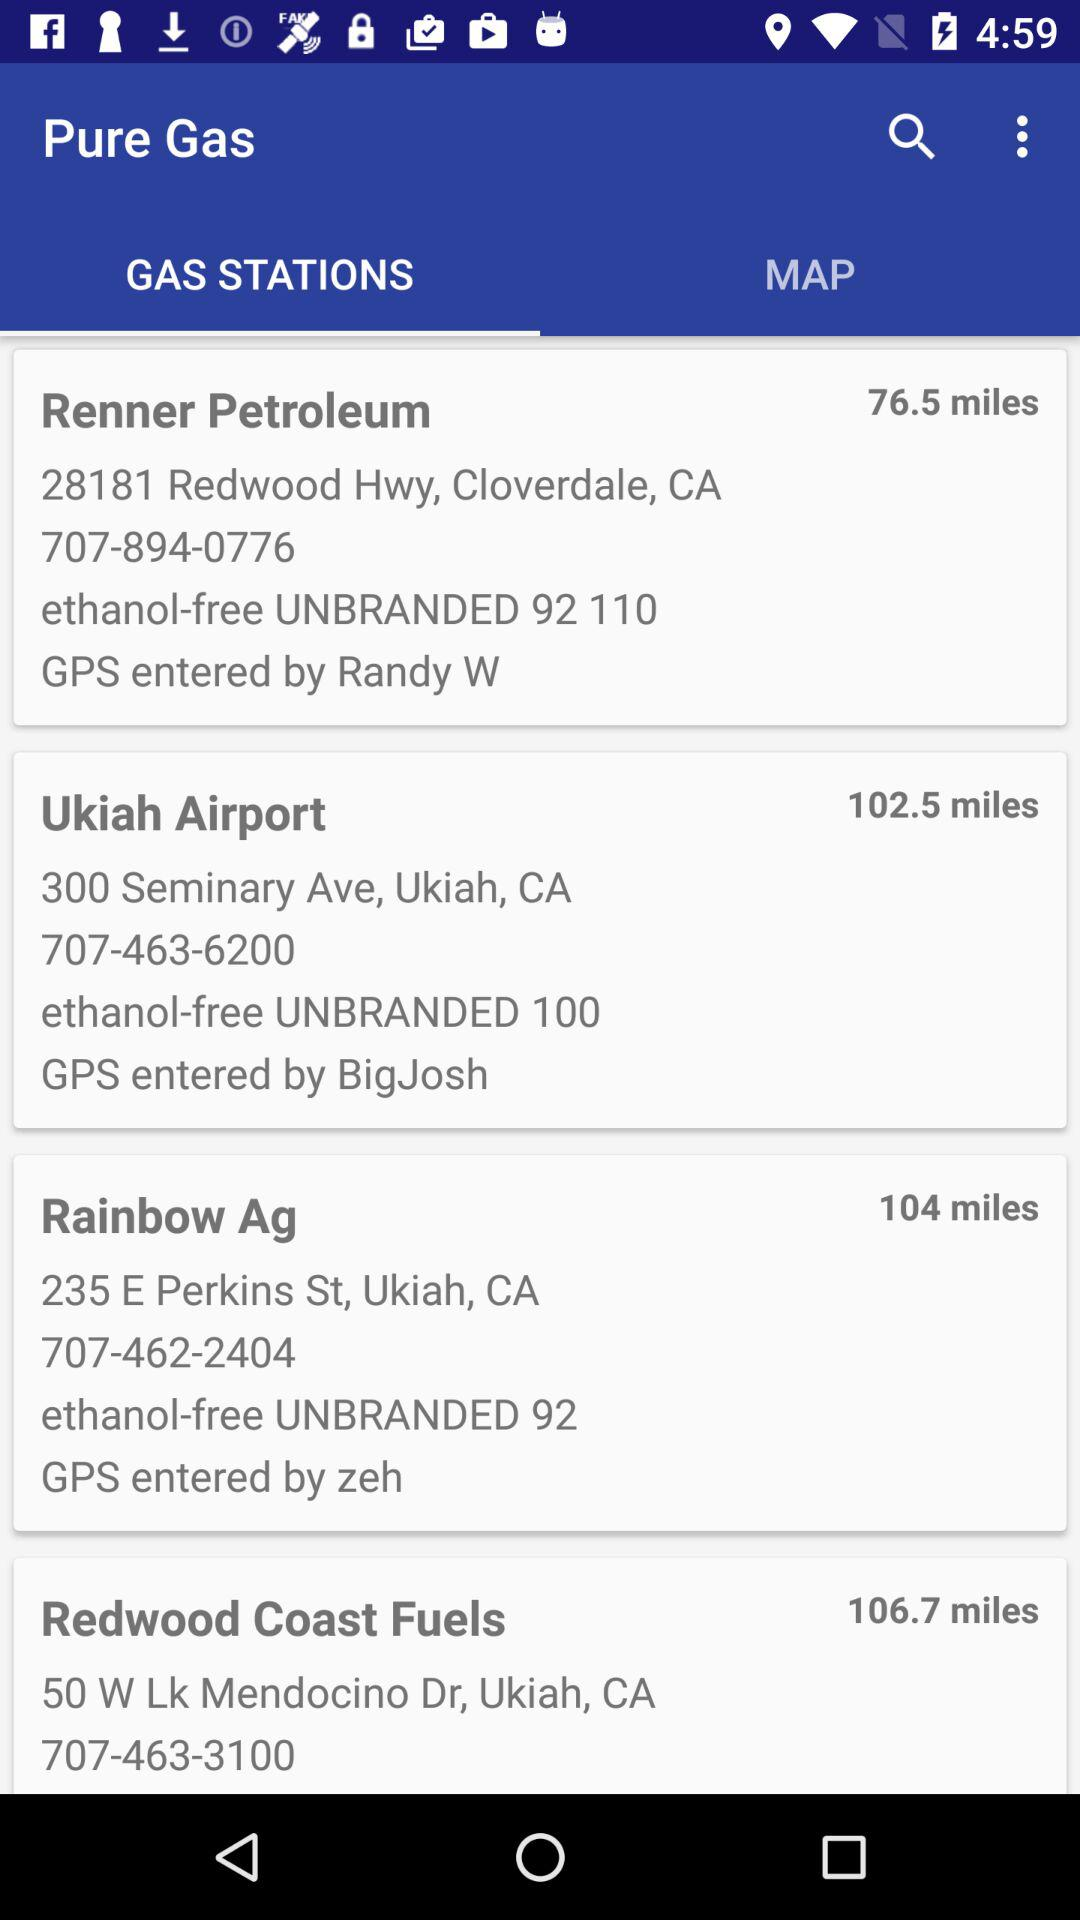What is the address of Ukiah Airport? The address is 300 Seminary Ave, Ukiah, CA. 